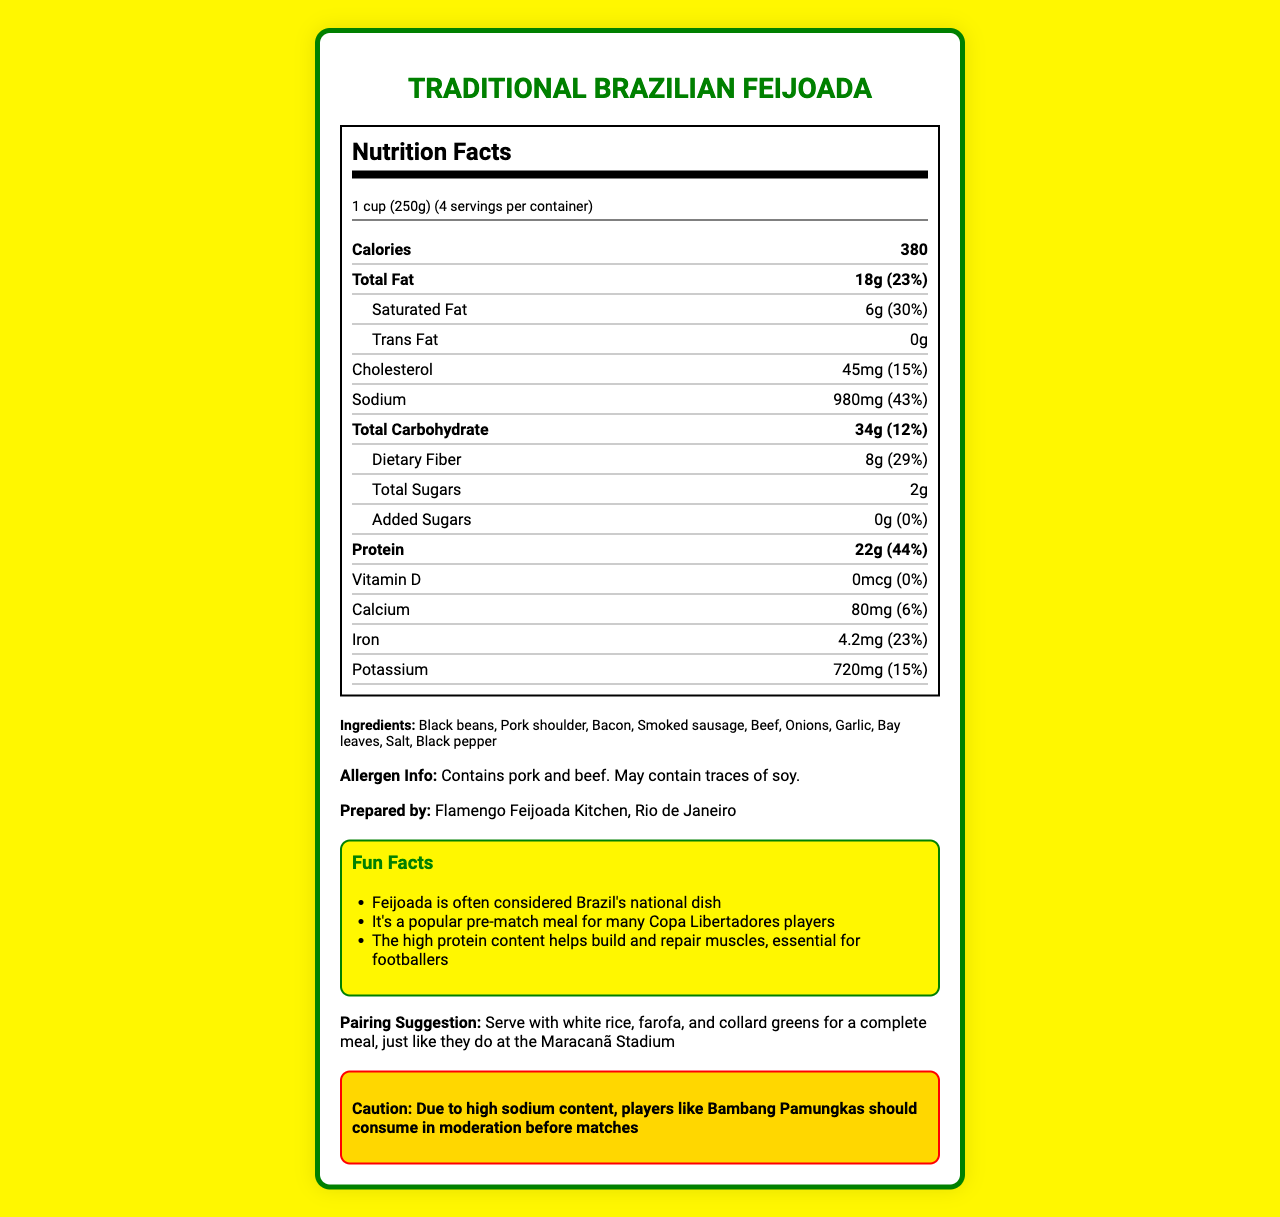what is the serving size for the traditional Brazilian feijoada? The serving size is stated at the beginning of the nutrition facts section.
Answer: 1 cup (250g) how many servings are in one container? The number of servings per container is mentioned right below the serving size.
Answer: 4 how many calories are there per serving? The number of calories per serving is highlighted near the top of the nutrition label.
Answer: 380 what is the total fat content per serving? The total fat content per serving is listed in the nutrition label section.
Answer: 18g what is the sodium content per serving? The sodium content per serving is clearly stated in the middle portion of the nutrition label.
Answer: 980mg what is the protein content per serving? The protein content per serving is located towards the end of the nutrition label.
Answer: 22g which ingredient in the feijoada is a common allergen? A. Onions B. Soy C. Bay leaves D. Salt The allergen information mentions that the dish "May contain traces of soy."
Answer: B what percentage of the daily value is saturated fat per serving? The percentage of the daily value for saturated fat is located right next to its amount.
Answer: 30% how many grams of dietary fiber are in a serving? A. 4g B. 6g C. 8g D. 10g The nutrition label states that dietary fiber per serving is 8g.
Answer: C is the traditional Brazilian feijoada high in protein? The protein content per serving is 22g, which is 44% of the daily value, indicating high protein content.
Answer: Yes summarize the general nutritional profile of the traditional Brazilian feijoada. The feijoada's nutrition label indicates a balanced but rich composition with significant protein and sodium levels, making it a hearty dish.
Answer: The traditional Brazilian feijoada provides 380 calories per serving with 18g of total fat, 980mg of sodium, 34g of carbohydrates, and 22g of protein. It is high in protein and sodium, and also contains dietary fiber. what is the main ingredient in the traditional Brazilian feijoada? The first ingredient listed is typically the primary one, which in this case is black beans.
Answer: Black beans which mineral in the feijoada has the highest daily value percentage? A. Calcium B. Iron C. Potassium D. Sodium Sodium has 43% of the daily value, which is higher than the other minerals mentioned.
Answer: D is "Feijoada a popular pre-match meal for many Copa Libertadores players?" This information is part of the fun facts provided at the end of the document.
Answer: True how many grams of added sugars are in a serving? The nutrition label indicates that there are no added sugars in a serving.
Answer: 0g what dish pairs well with the traditional Brazilian feijoada? The pairing suggestion mentioned in the document indicates these dishes.
Answer: White rice, farofa, and collard greens who prepared the traditional Brazilian feijoada? This information is located towards the end of the document under "Prepared by."
Answer: Flamengo Feijoada Kitchen, Rio de Janeiro what is the total carbohydrate content per serving? The total carbohydrate content per serving is listed in the nutrition facts.
Answer: 34g is the traditional Brazilian feijoada suitable for someone who needs to avoid high sodium foods? The sodium content per serving is 980mg, which is 43% of the daily value, indicating it is high in sodium.
Answer: No can you determine the exact amount of vitamin D in a serving of the feijoada? The nutrition label specifies that there is 0mcg of vitamin D in a serving.
Answer: 0mcg what fun fact is related to the high protein content of the feijoada? This is one of the fun facts mentioned towards the end of the document.
Answer: The high protein content helps build and repair muscles, essential for footballers what caution is given for players like Bambang Pamungkas regarding the feijoada? The caution note at the end of the document provides this information.
Answer: Due to high sodium content, players like Bambang Pamungkas should consume in moderation before matches what is the cholesterol content per serving? The cholesterol content per serving is listed in the nutrition label.
Answer: 45mg who is your favorite Copa Libertadores team currently? The document does not provide any information regarding personal preferences on Copa Libertadores teams.
Answer: Can't be determined 